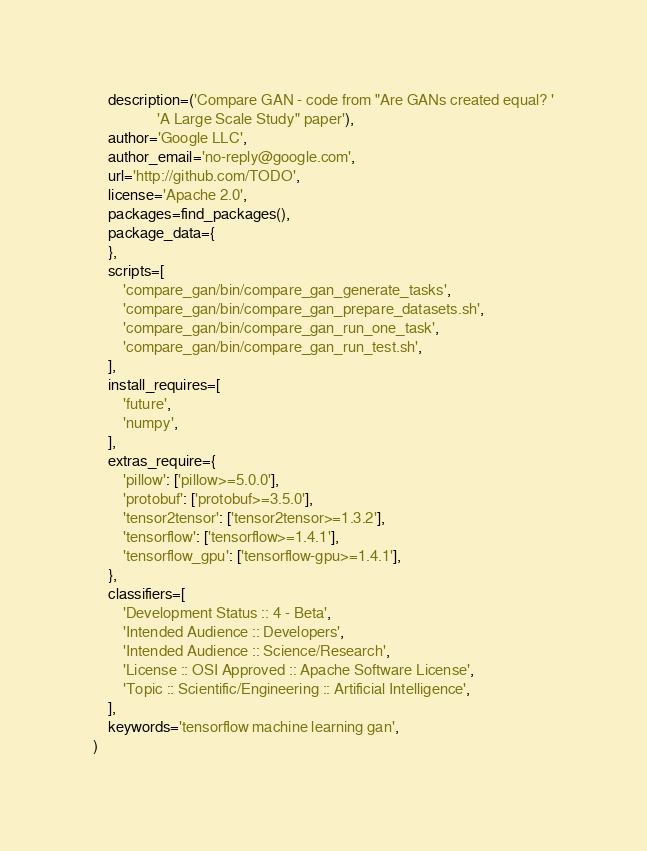<code> <loc_0><loc_0><loc_500><loc_500><_Python_>    description=('Compare GAN - code from "Are GANs created equal? '
                 'A Large Scale Study" paper'),
    author='Google LLC',
    author_email='no-reply@google.com',
    url='http://github.com/TODO',
    license='Apache 2.0',
    packages=find_packages(),
    package_data={
    },
    scripts=[
        'compare_gan/bin/compare_gan_generate_tasks',
        'compare_gan/bin/compare_gan_prepare_datasets.sh',
        'compare_gan/bin/compare_gan_run_one_task',
        'compare_gan/bin/compare_gan_run_test.sh',
    ],
    install_requires=[
        'future',
        'numpy',
    ],
    extras_require={
        'pillow': ['pillow>=5.0.0'],
        'protobuf': ['protobuf>=3.5.0'],
        'tensor2tensor': ['tensor2tensor>=1.3.2'],
        'tensorflow': ['tensorflow>=1.4.1'],
        'tensorflow_gpu': ['tensorflow-gpu>=1.4.1'],
    },
    classifiers=[
        'Development Status :: 4 - Beta',
        'Intended Audience :: Developers',
        'Intended Audience :: Science/Research',
        'License :: OSI Approved :: Apache Software License',
        'Topic :: Scientific/Engineering :: Artificial Intelligence',
    ],
    keywords='tensorflow machine learning gan',
)
</code> 